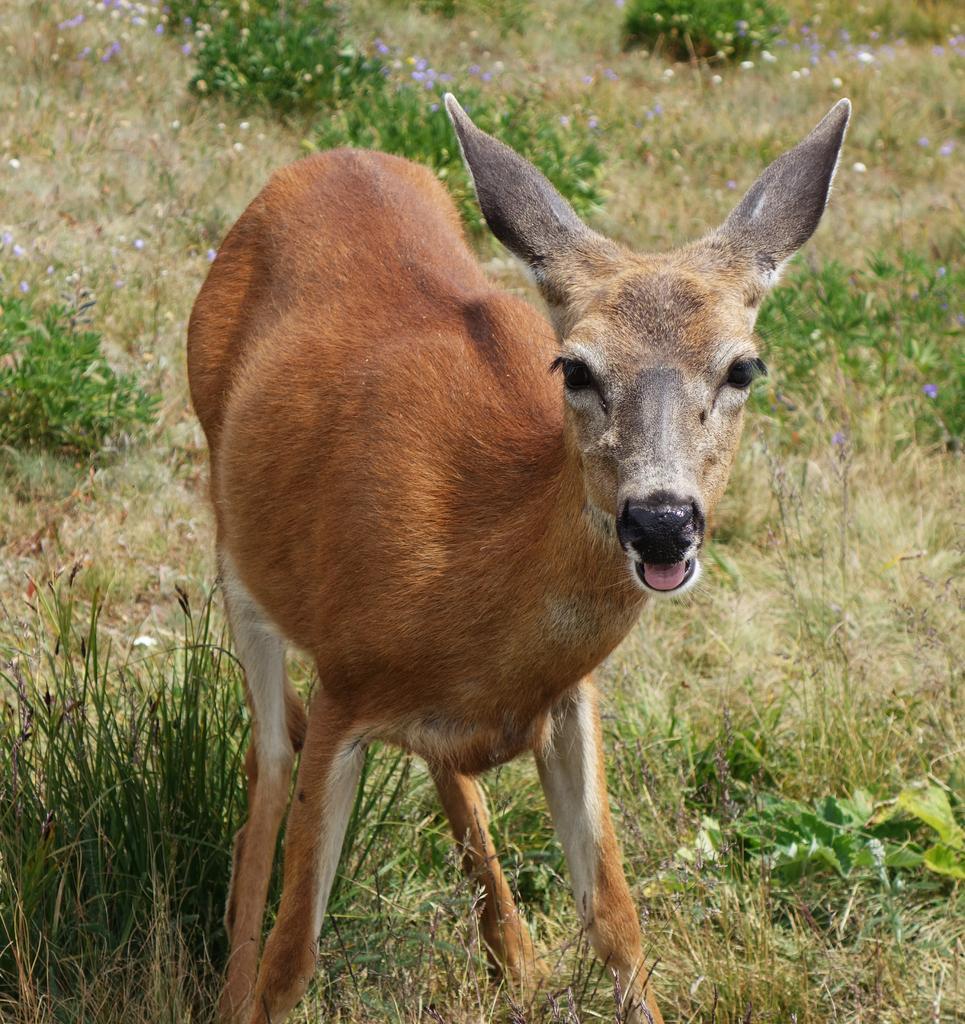Could you give a brief overview of what you see in this image? There is a deer in the foreground area of the image on the grassland, it seems like small flower plants and grassland in the background. 